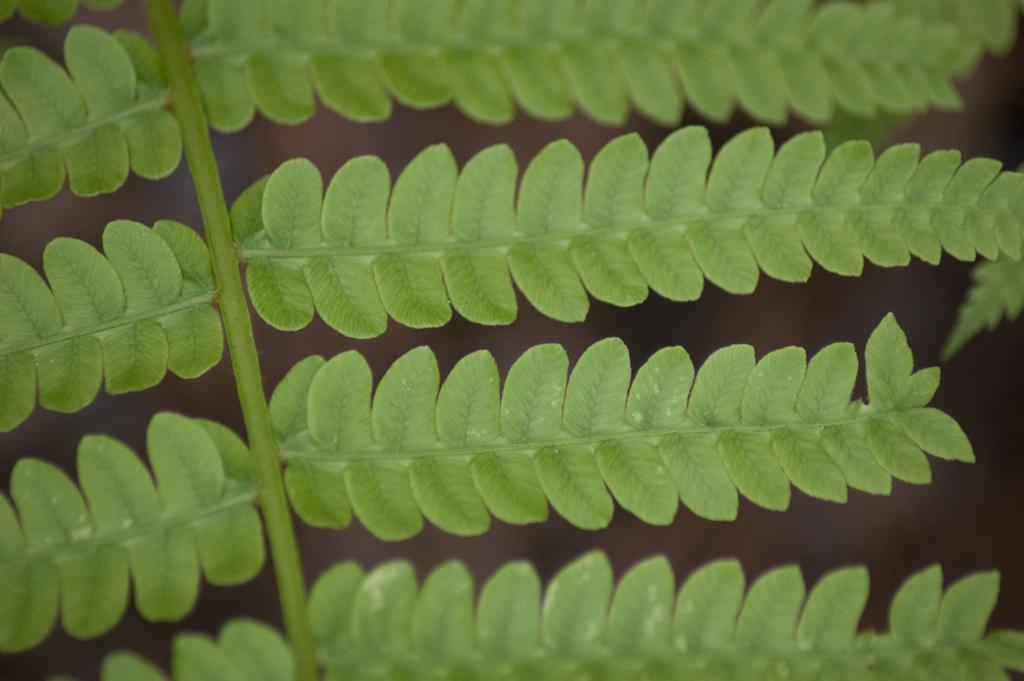What is the main subject of the image? The main subject of the image is a stem with leaves. What can be observed about the color of the leaves? The leaves are green in color. How would you describe the background of the image? The background appears blurry. How many children are playing near the lake in the image? There is no lake or children present in the image; it features a stem with green leaves and a blurry background. 